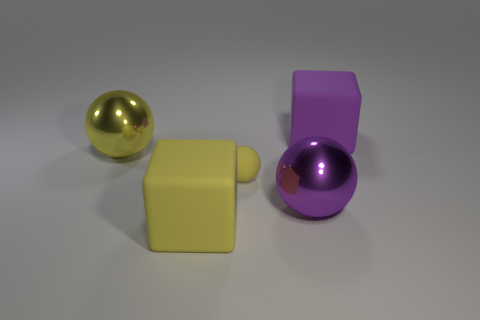The small sphere has what color?
Your answer should be very brief. Yellow. How many purple rubber cubes are to the left of the tiny yellow matte sphere left of the large purple sphere?
Provide a succinct answer. 0. Does the yellow shiny object have the same size as the purple matte thing that is to the right of the small yellow matte ball?
Give a very brief answer. Yes. Is the yellow cube the same size as the yellow shiny thing?
Offer a terse response. Yes. Are there any things of the same size as the purple rubber block?
Keep it short and to the point. Yes. What is the material of the block that is behind the big purple metallic object?
Provide a succinct answer. Rubber. The other ball that is the same material as the purple sphere is what color?
Your answer should be compact. Yellow. How many shiny objects are either green things or small yellow things?
Your answer should be compact. 0. What is the shape of the metal thing that is the same size as the purple metallic sphere?
Your answer should be very brief. Sphere. How many objects are either matte objects left of the small rubber object or spheres to the left of the big purple shiny ball?
Your answer should be very brief. 3. 